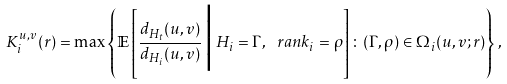<formula> <loc_0><loc_0><loc_500><loc_500>K _ { i } ^ { u , v } ( r ) = \max \left \{ \mathbb { E } \left [ \frac { d _ { H _ { t } } ( u , v ) } { d _ { H _ { i } } ( u , v ) } \, \Big | \, H _ { i } = \Gamma , \ r a n k _ { i } = \rho \right ] \colon ( \Gamma , \rho ) \in \Omega _ { i } ( u , v ; r ) \right \} ,</formula> 